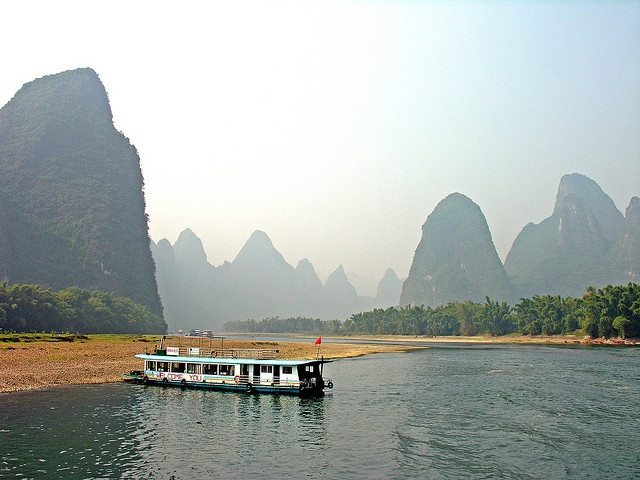Describe the objects in this image and their specific colors. I can see a boat in white, black, ivory, darkgray, and gray tones in this image. 